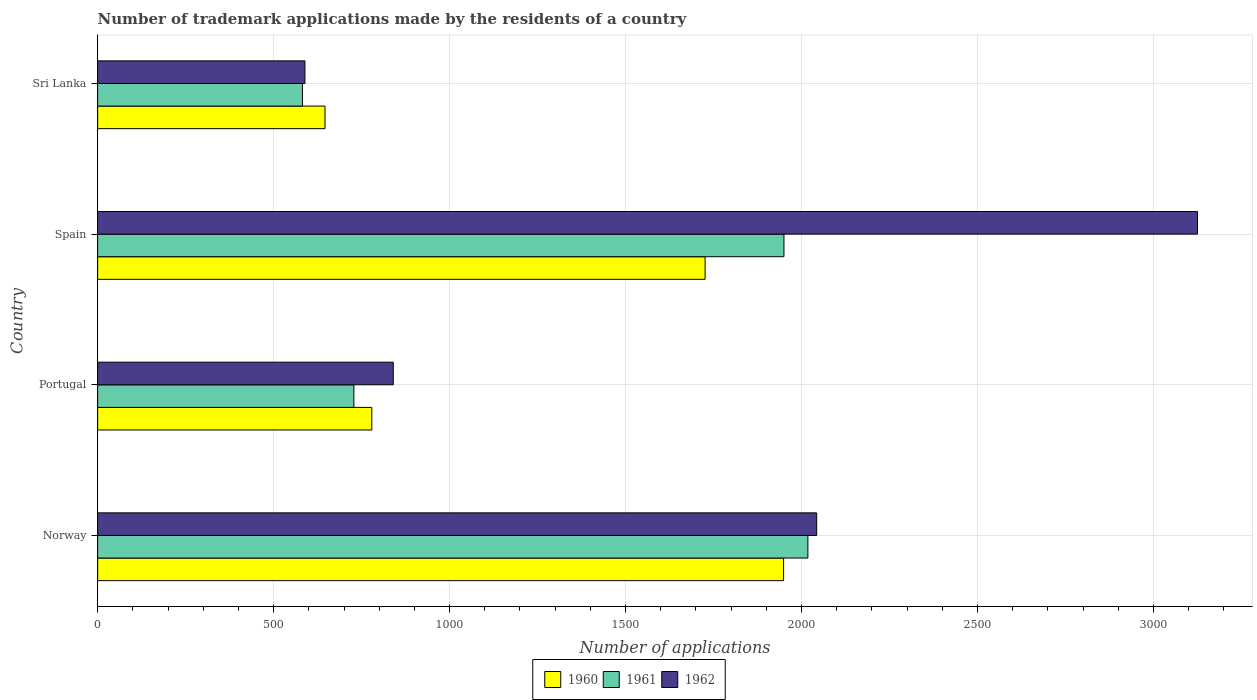Are the number of bars on each tick of the Y-axis equal?
Offer a very short reply. Yes. What is the label of the 1st group of bars from the top?
Provide a short and direct response. Sri Lanka. What is the number of trademark applications made by the residents in 1961 in Norway?
Offer a terse response. 2018. Across all countries, what is the maximum number of trademark applications made by the residents in 1961?
Make the answer very short. 2018. Across all countries, what is the minimum number of trademark applications made by the residents in 1962?
Ensure brevity in your answer.  589. In which country was the number of trademark applications made by the residents in 1961 minimum?
Your answer should be compact. Sri Lanka. What is the total number of trademark applications made by the residents in 1960 in the graph?
Keep it short and to the point. 5100. What is the difference between the number of trademark applications made by the residents in 1961 in Norway and that in Sri Lanka?
Your answer should be compact. 1436. What is the difference between the number of trademark applications made by the residents in 1962 in Norway and the number of trademark applications made by the residents in 1960 in Portugal?
Your response must be concise. 1264. What is the average number of trademark applications made by the residents in 1961 per country?
Provide a succinct answer. 1319.5. In how many countries, is the number of trademark applications made by the residents in 1961 greater than 2600 ?
Provide a succinct answer. 0. What is the ratio of the number of trademark applications made by the residents in 1960 in Norway to that in Spain?
Provide a succinct answer. 1.13. Is the difference between the number of trademark applications made by the residents in 1960 in Portugal and Sri Lanka greater than the difference between the number of trademark applications made by the residents in 1961 in Portugal and Sri Lanka?
Give a very brief answer. No. What is the difference between the highest and the second highest number of trademark applications made by the residents in 1961?
Provide a short and direct response. 68. What is the difference between the highest and the lowest number of trademark applications made by the residents in 1962?
Give a very brief answer. 2536. How many bars are there?
Ensure brevity in your answer.  12. How many countries are there in the graph?
Give a very brief answer. 4. What is the difference between two consecutive major ticks on the X-axis?
Give a very brief answer. 500. Are the values on the major ticks of X-axis written in scientific E-notation?
Provide a succinct answer. No. Does the graph contain grids?
Your answer should be very brief. Yes. Where does the legend appear in the graph?
Offer a terse response. Bottom center. How many legend labels are there?
Make the answer very short. 3. How are the legend labels stacked?
Your answer should be compact. Horizontal. What is the title of the graph?
Offer a terse response. Number of trademark applications made by the residents of a country. Does "1964" appear as one of the legend labels in the graph?
Your answer should be compact. No. What is the label or title of the X-axis?
Provide a short and direct response. Number of applications. What is the label or title of the Y-axis?
Keep it short and to the point. Country. What is the Number of applications in 1960 in Norway?
Offer a terse response. 1949. What is the Number of applications of 1961 in Norway?
Offer a very short reply. 2018. What is the Number of applications of 1962 in Norway?
Keep it short and to the point. 2043. What is the Number of applications in 1960 in Portugal?
Give a very brief answer. 779. What is the Number of applications in 1961 in Portugal?
Offer a very short reply. 728. What is the Number of applications of 1962 in Portugal?
Offer a terse response. 840. What is the Number of applications of 1960 in Spain?
Offer a very short reply. 1726. What is the Number of applications in 1961 in Spain?
Provide a succinct answer. 1950. What is the Number of applications of 1962 in Spain?
Your answer should be very brief. 3125. What is the Number of applications of 1960 in Sri Lanka?
Offer a very short reply. 646. What is the Number of applications of 1961 in Sri Lanka?
Provide a succinct answer. 582. What is the Number of applications in 1962 in Sri Lanka?
Your answer should be very brief. 589. Across all countries, what is the maximum Number of applications of 1960?
Provide a succinct answer. 1949. Across all countries, what is the maximum Number of applications of 1961?
Provide a short and direct response. 2018. Across all countries, what is the maximum Number of applications in 1962?
Offer a terse response. 3125. Across all countries, what is the minimum Number of applications of 1960?
Provide a short and direct response. 646. Across all countries, what is the minimum Number of applications in 1961?
Your answer should be compact. 582. Across all countries, what is the minimum Number of applications in 1962?
Provide a short and direct response. 589. What is the total Number of applications in 1960 in the graph?
Make the answer very short. 5100. What is the total Number of applications in 1961 in the graph?
Make the answer very short. 5278. What is the total Number of applications in 1962 in the graph?
Your response must be concise. 6597. What is the difference between the Number of applications in 1960 in Norway and that in Portugal?
Your answer should be very brief. 1170. What is the difference between the Number of applications of 1961 in Norway and that in Portugal?
Give a very brief answer. 1290. What is the difference between the Number of applications in 1962 in Norway and that in Portugal?
Make the answer very short. 1203. What is the difference between the Number of applications of 1960 in Norway and that in Spain?
Give a very brief answer. 223. What is the difference between the Number of applications of 1961 in Norway and that in Spain?
Provide a short and direct response. 68. What is the difference between the Number of applications of 1962 in Norway and that in Spain?
Keep it short and to the point. -1082. What is the difference between the Number of applications in 1960 in Norway and that in Sri Lanka?
Give a very brief answer. 1303. What is the difference between the Number of applications of 1961 in Norway and that in Sri Lanka?
Provide a short and direct response. 1436. What is the difference between the Number of applications in 1962 in Norway and that in Sri Lanka?
Your answer should be compact. 1454. What is the difference between the Number of applications of 1960 in Portugal and that in Spain?
Provide a succinct answer. -947. What is the difference between the Number of applications of 1961 in Portugal and that in Spain?
Offer a terse response. -1222. What is the difference between the Number of applications of 1962 in Portugal and that in Spain?
Offer a very short reply. -2285. What is the difference between the Number of applications of 1960 in Portugal and that in Sri Lanka?
Offer a very short reply. 133. What is the difference between the Number of applications of 1961 in Portugal and that in Sri Lanka?
Give a very brief answer. 146. What is the difference between the Number of applications in 1962 in Portugal and that in Sri Lanka?
Keep it short and to the point. 251. What is the difference between the Number of applications in 1960 in Spain and that in Sri Lanka?
Provide a short and direct response. 1080. What is the difference between the Number of applications in 1961 in Spain and that in Sri Lanka?
Provide a succinct answer. 1368. What is the difference between the Number of applications in 1962 in Spain and that in Sri Lanka?
Give a very brief answer. 2536. What is the difference between the Number of applications in 1960 in Norway and the Number of applications in 1961 in Portugal?
Keep it short and to the point. 1221. What is the difference between the Number of applications of 1960 in Norway and the Number of applications of 1962 in Portugal?
Offer a terse response. 1109. What is the difference between the Number of applications in 1961 in Norway and the Number of applications in 1962 in Portugal?
Give a very brief answer. 1178. What is the difference between the Number of applications of 1960 in Norway and the Number of applications of 1962 in Spain?
Keep it short and to the point. -1176. What is the difference between the Number of applications in 1961 in Norway and the Number of applications in 1962 in Spain?
Keep it short and to the point. -1107. What is the difference between the Number of applications of 1960 in Norway and the Number of applications of 1961 in Sri Lanka?
Provide a succinct answer. 1367. What is the difference between the Number of applications of 1960 in Norway and the Number of applications of 1962 in Sri Lanka?
Make the answer very short. 1360. What is the difference between the Number of applications of 1961 in Norway and the Number of applications of 1962 in Sri Lanka?
Provide a succinct answer. 1429. What is the difference between the Number of applications in 1960 in Portugal and the Number of applications in 1961 in Spain?
Offer a terse response. -1171. What is the difference between the Number of applications in 1960 in Portugal and the Number of applications in 1962 in Spain?
Offer a very short reply. -2346. What is the difference between the Number of applications of 1961 in Portugal and the Number of applications of 1962 in Spain?
Offer a terse response. -2397. What is the difference between the Number of applications of 1960 in Portugal and the Number of applications of 1961 in Sri Lanka?
Provide a succinct answer. 197. What is the difference between the Number of applications in 1960 in Portugal and the Number of applications in 1962 in Sri Lanka?
Make the answer very short. 190. What is the difference between the Number of applications in 1961 in Portugal and the Number of applications in 1962 in Sri Lanka?
Provide a short and direct response. 139. What is the difference between the Number of applications of 1960 in Spain and the Number of applications of 1961 in Sri Lanka?
Make the answer very short. 1144. What is the difference between the Number of applications of 1960 in Spain and the Number of applications of 1962 in Sri Lanka?
Keep it short and to the point. 1137. What is the difference between the Number of applications of 1961 in Spain and the Number of applications of 1962 in Sri Lanka?
Your answer should be very brief. 1361. What is the average Number of applications of 1960 per country?
Ensure brevity in your answer.  1275. What is the average Number of applications in 1961 per country?
Your answer should be very brief. 1319.5. What is the average Number of applications of 1962 per country?
Keep it short and to the point. 1649.25. What is the difference between the Number of applications in 1960 and Number of applications in 1961 in Norway?
Provide a succinct answer. -69. What is the difference between the Number of applications of 1960 and Number of applications of 1962 in Norway?
Provide a short and direct response. -94. What is the difference between the Number of applications in 1960 and Number of applications in 1962 in Portugal?
Keep it short and to the point. -61. What is the difference between the Number of applications in 1961 and Number of applications in 1962 in Portugal?
Your response must be concise. -112. What is the difference between the Number of applications of 1960 and Number of applications of 1961 in Spain?
Keep it short and to the point. -224. What is the difference between the Number of applications in 1960 and Number of applications in 1962 in Spain?
Offer a terse response. -1399. What is the difference between the Number of applications of 1961 and Number of applications of 1962 in Spain?
Give a very brief answer. -1175. What is the difference between the Number of applications of 1960 and Number of applications of 1961 in Sri Lanka?
Give a very brief answer. 64. What is the ratio of the Number of applications of 1960 in Norway to that in Portugal?
Ensure brevity in your answer.  2.5. What is the ratio of the Number of applications in 1961 in Norway to that in Portugal?
Offer a terse response. 2.77. What is the ratio of the Number of applications in 1962 in Norway to that in Portugal?
Keep it short and to the point. 2.43. What is the ratio of the Number of applications in 1960 in Norway to that in Spain?
Offer a terse response. 1.13. What is the ratio of the Number of applications in 1961 in Norway to that in Spain?
Your response must be concise. 1.03. What is the ratio of the Number of applications of 1962 in Norway to that in Spain?
Provide a succinct answer. 0.65. What is the ratio of the Number of applications in 1960 in Norway to that in Sri Lanka?
Your response must be concise. 3.02. What is the ratio of the Number of applications in 1961 in Norway to that in Sri Lanka?
Make the answer very short. 3.47. What is the ratio of the Number of applications of 1962 in Norway to that in Sri Lanka?
Your answer should be compact. 3.47. What is the ratio of the Number of applications in 1960 in Portugal to that in Spain?
Offer a very short reply. 0.45. What is the ratio of the Number of applications in 1961 in Portugal to that in Spain?
Offer a terse response. 0.37. What is the ratio of the Number of applications in 1962 in Portugal to that in Spain?
Your response must be concise. 0.27. What is the ratio of the Number of applications in 1960 in Portugal to that in Sri Lanka?
Give a very brief answer. 1.21. What is the ratio of the Number of applications of 1961 in Portugal to that in Sri Lanka?
Offer a very short reply. 1.25. What is the ratio of the Number of applications in 1962 in Portugal to that in Sri Lanka?
Give a very brief answer. 1.43. What is the ratio of the Number of applications of 1960 in Spain to that in Sri Lanka?
Provide a short and direct response. 2.67. What is the ratio of the Number of applications in 1961 in Spain to that in Sri Lanka?
Keep it short and to the point. 3.35. What is the ratio of the Number of applications in 1962 in Spain to that in Sri Lanka?
Make the answer very short. 5.31. What is the difference between the highest and the second highest Number of applications of 1960?
Ensure brevity in your answer.  223. What is the difference between the highest and the second highest Number of applications in 1962?
Your answer should be compact. 1082. What is the difference between the highest and the lowest Number of applications of 1960?
Your answer should be compact. 1303. What is the difference between the highest and the lowest Number of applications in 1961?
Your response must be concise. 1436. What is the difference between the highest and the lowest Number of applications of 1962?
Offer a very short reply. 2536. 